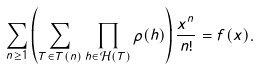<formula> <loc_0><loc_0><loc_500><loc_500>\sum _ { n \geq 1 } \left ( \sum _ { T \in T ( n ) } \prod _ { h \in \mathcal { H } ( T ) } \rho ( h ) \right ) \frac { x ^ { n } } { n ! } = f ( x ) .</formula> 